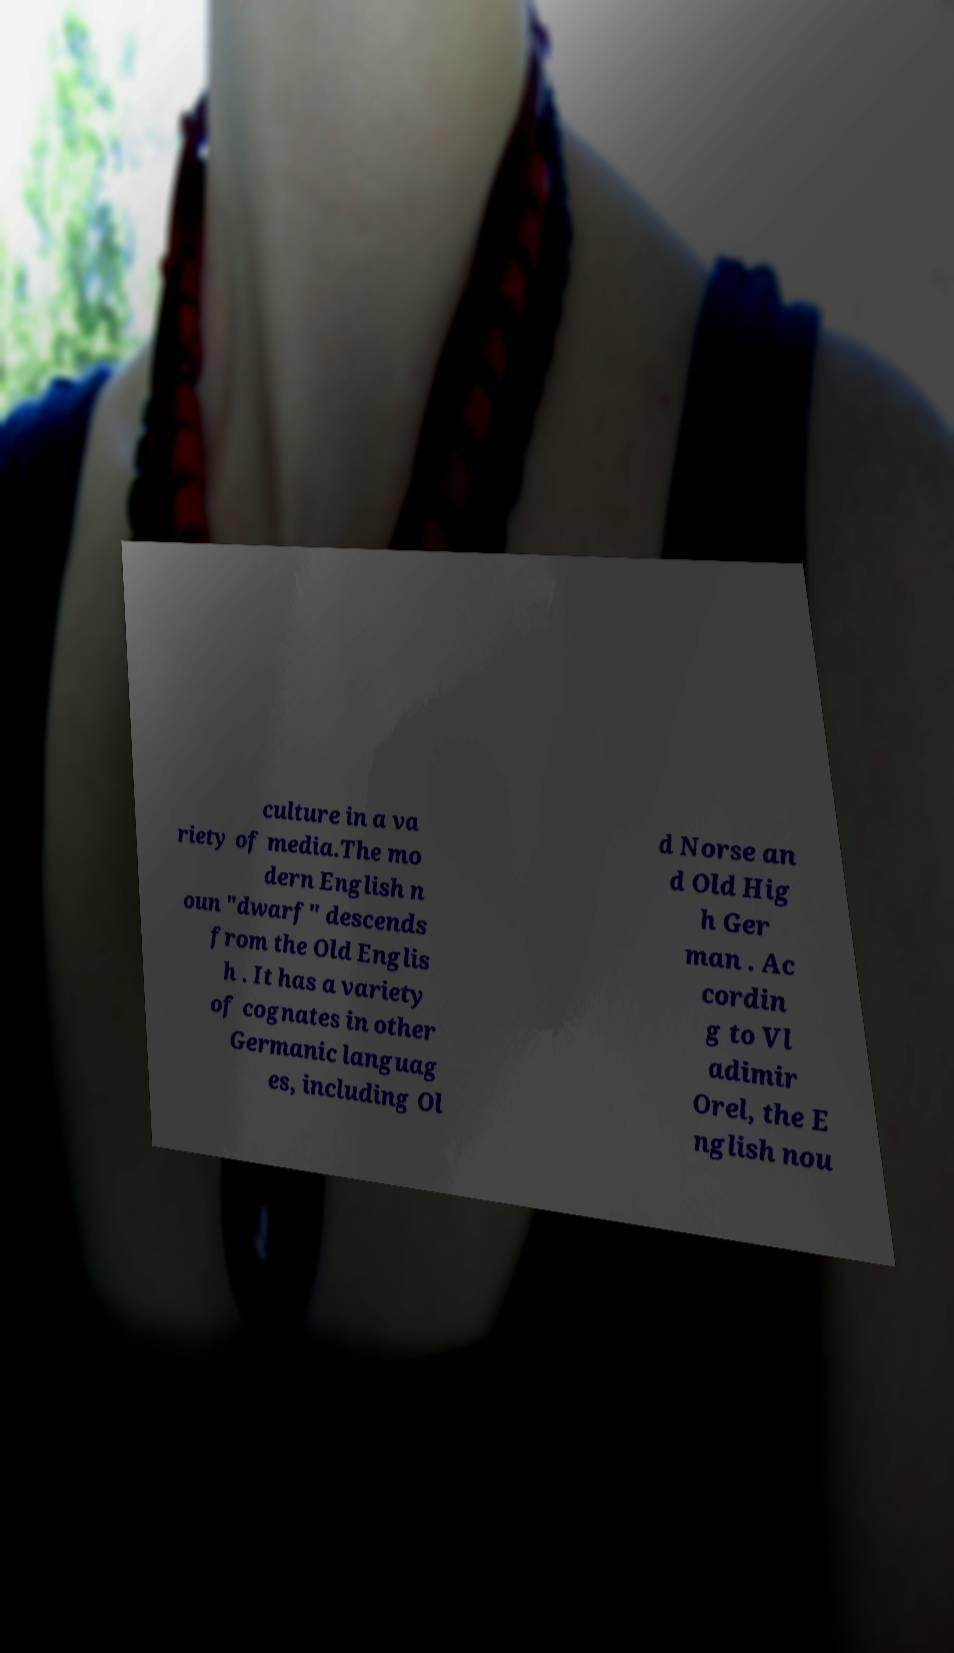There's text embedded in this image that I need extracted. Can you transcribe it verbatim? culture in a va riety of media.The mo dern English n oun "dwarf" descends from the Old Englis h . It has a variety of cognates in other Germanic languag es, including Ol d Norse an d Old Hig h Ger man . Ac cordin g to Vl adimir Orel, the E nglish nou 